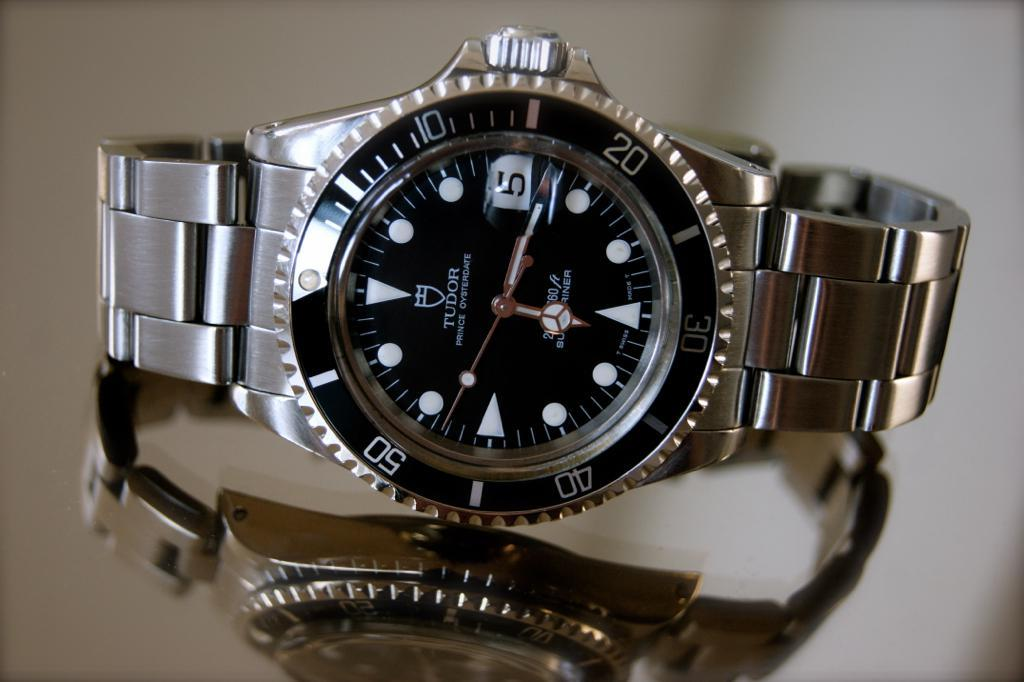<image>
Provide a brief description of the given image. A metal Tudor watch sits on a reflective surface. 